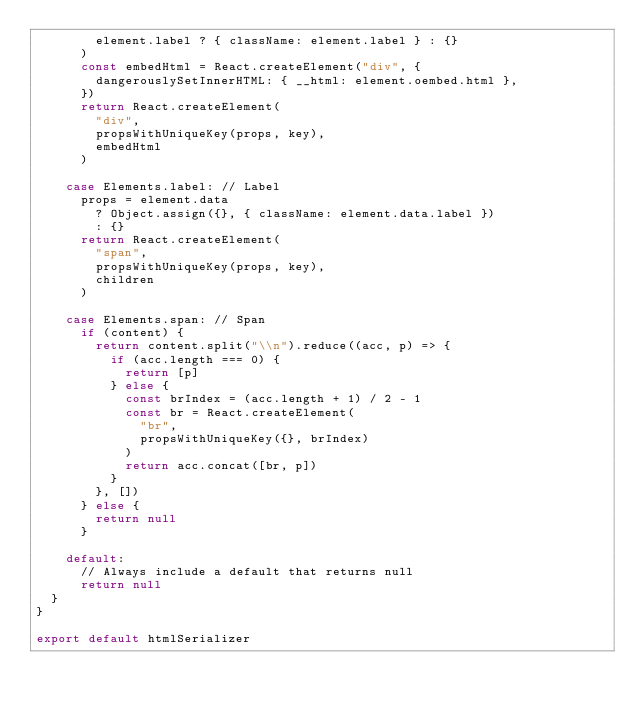Convert code to text. <code><loc_0><loc_0><loc_500><loc_500><_JavaScript_>        element.label ? { className: element.label } : {}
      )
      const embedHtml = React.createElement("div", {
        dangerouslySetInnerHTML: { __html: element.oembed.html },
      })
      return React.createElement(
        "div",
        propsWithUniqueKey(props, key),
        embedHtml
      )

    case Elements.label: // Label
      props = element.data
        ? Object.assign({}, { className: element.data.label })
        : {}
      return React.createElement(
        "span",
        propsWithUniqueKey(props, key),
        children
      )

    case Elements.span: // Span
      if (content) {
        return content.split("\\n").reduce((acc, p) => {
          if (acc.length === 0) {
            return [p]
          } else {
            const brIndex = (acc.length + 1) / 2 - 1
            const br = React.createElement(
              "br",
              propsWithUniqueKey({}, brIndex)
            )
            return acc.concat([br, p])
          }
        }, [])
      } else {
        return null
      }

    default:
      // Always include a default that returns null
      return null
  }
}

export default htmlSerializer
</code> 